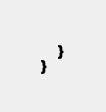<code> <loc_0><loc_0><loc_500><loc_500><_PHP_>    }
}
</code> 